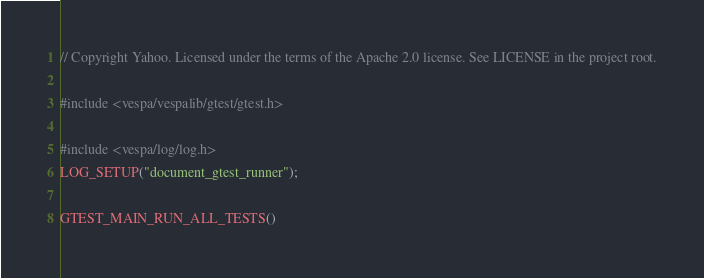Convert code to text. <code><loc_0><loc_0><loc_500><loc_500><_C++_>// Copyright Yahoo. Licensed under the terms of the Apache 2.0 license. See LICENSE in the project root.

#include <vespa/vespalib/gtest/gtest.h>

#include <vespa/log/log.h>
LOG_SETUP("document_gtest_runner");

GTEST_MAIN_RUN_ALL_TESTS()
</code> 